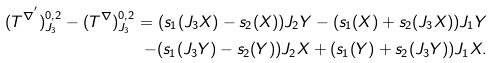Convert formula to latex. <formula><loc_0><loc_0><loc_500><loc_500>( T ^ { \nabla ^ { ^ { \prime } } } ) ^ { 0 , 2 } _ { J _ { 3 } } - ( T ^ { \nabla } ) ^ { 0 , 2 } _ { J _ { 3 } } = ( s _ { 1 } ( J _ { 3 } X ) - s _ { 2 } ( X ) ) J _ { 2 } Y - ( s _ { 1 } ( X ) + s _ { 2 } ( J _ { 3 } X ) ) J _ { 1 } Y \\ - ( s _ { 1 } ( J _ { 3 } Y ) - s _ { 2 } ( Y ) ) J _ { 2 } X + ( s _ { 1 } ( Y ) + s _ { 2 } ( J _ { 3 } Y ) ) J _ { 1 } X .</formula> 